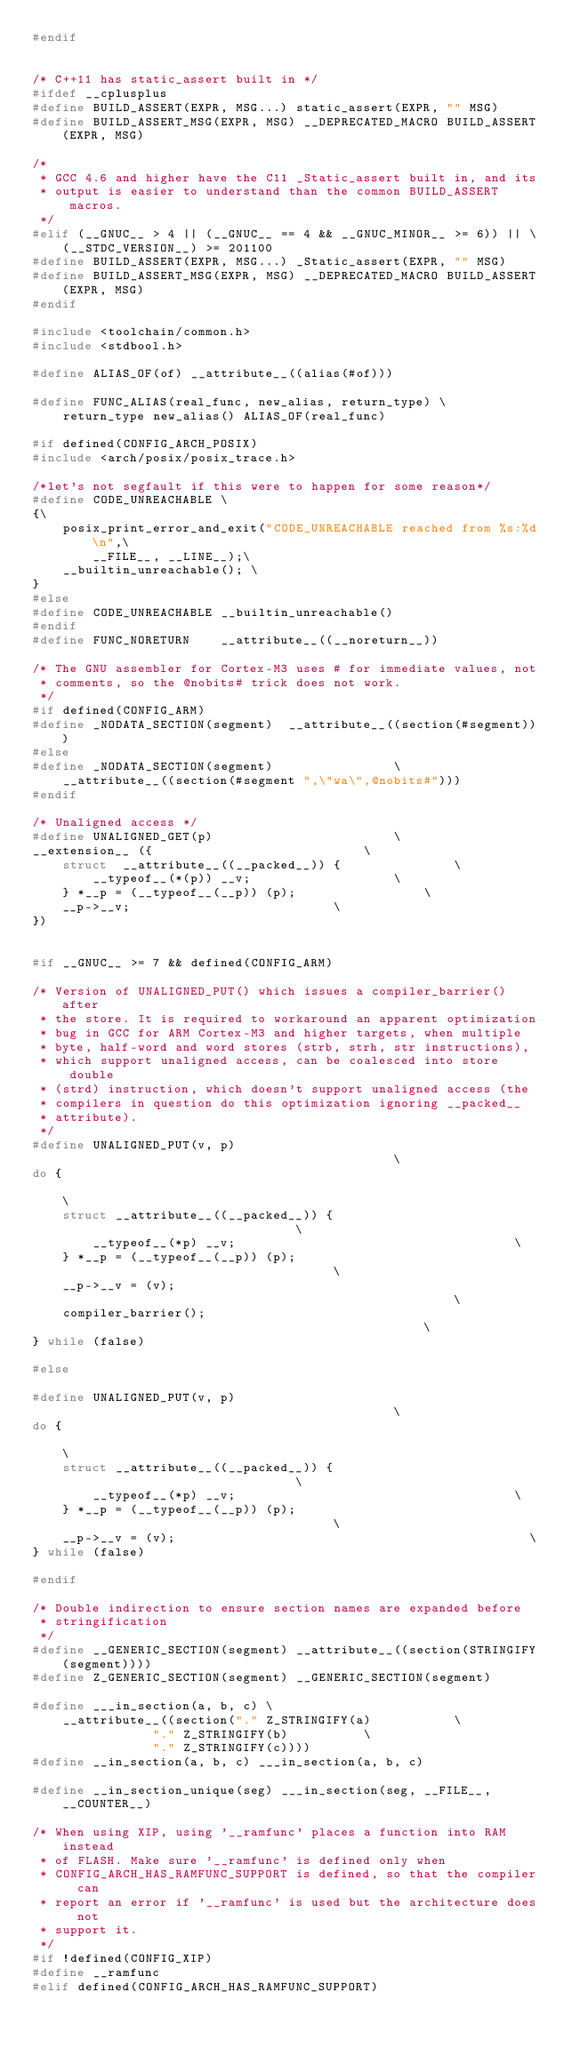<code> <loc_0><loc_0><loc_500><loc_500><_C_>#endif


/* C++11 has static_assert built in */
#ifdef __cplusplus
#define BUILD_ASSERT(EXPR, MSG...) static_assert(EXPR, "" MSG)
#define BUILD_ASSERT_MSG(EXPR, MSG) __DEPRECATED_MACRO BUILD_ASSERT(EXPR, MSG)

/*
 * GCC 4.6 and higher have the C11 _Static_assert built in, and its
 * output is easier to understand than the common BUILD_ASSERT macros.
 */
#elif (__GNUC__ > 4 || (__GNUC__ == 4 && __GNUC_MINOR__ >= 6)) || \
	(__STDC_VERSION__) >= 201100
#define BUILD_ASSERT(EXPR, MSG...) _Static_assert(EXPR, "" MSG)
#define BUILD_ASSERT_MSG(EXPR, MSG) __DEPRECATED_MACRO BUILD_ASSERT(EXPR, MSG)
#endif

#include <toolchain/common.h>
#include <stdbool.h>

#define ALIAS_OF(of) __attribute__((alias(#of)))

#define FUNC_ALIAS(real_func, new_alias, return_type) \
	return_type new_alias() ALIAS_OF(real_func)

#if defined(CONFIG_ARCH_POSIX)
#include <arch/posix/posix_trace.h>

/*let's not segfault if this were to happen for some reason*/
#define CODE_UNREACHABLE \
{\
	posix_print_error_and_exit("CODE_UNREACHABLE reached from %s:%d\n",\
		__FILE__, __LINE__);\
	__builtin_unreachable(); \
}
#else
#define CODE_UNREACHABLE __builtin_unreachable()
#endif
#define FUNC_NORETURN    __attribute__((__noreturn__))

/* The GNU assembler for Cortex-M3 uses # for immediate values, not
 * comments, so the @nobits# trick does not work.
 */
#if defined(CONFIG_ARM)
#define _NODATA_SECTION(segment)  __attribute__((section(#segment)))
#else
#define _NODATA_SECTION(segment)				\
	__attribute__((section(#segment ",\"wa\",@nobits#")))
#endif

/* Unaligned access */
#define UNALIGNED_GET(p)						\
__extension__ ({							\
	struct  __attribute__((__packed__)) {				\
		__typeof__(*(p)) __v;					\
	} *__p = (__typeof__(__p)) (p);					\
	__p->__v;							\
})


#if __GNUC__ >= 7 && defined(CONFIG_ARM)

/* Version of UNALIGNED_PUT() which issues a compiler_barrier() after
 * the store. It is required to workaround an apparent optimization
 * bug in GCC for ARM Cortex-M3 and higher targets, when multiple
 * byte, half-word and word stores (strb, strh, str instructions),
 * which support unaligned access, can be coalesced into store double
 * (strd) instruction, which doesn't support unaligned access (the
 * compilers in question do this optimization ignoring __packed__
 * attribute).
 */
#define UNALIGNED_PUT(v, p)                                             \
do {                                                                    \
	struct __attribute__((__packed__)) {                            \
		__typeof__(*p) __v;                                     \
	} *__p = (__typeof__(__p)) (p);                                 \
	__p->__v = (v);                                                 \
	compiler_barrier();                                             \
} while (false)

#else

#define UNALIGNED_PUT(v, p)                                             \
do {                                                                    \
	struct __attribute__((__packed__)) {                            \
		__typeof__(*p) __v;                                     \
	} *__p = (__typeof__(__p)) (p);                                 \
	__p->__v = (v);                                               \
} while (false)

#endif

/* Double indirection to ensure section names are expanded before
 * stringification
 */
#define __GENERIC_SECTION(segment) __attribute__((section(STRINGIFY(segment))))
#define Z_GENERIC_SECTION(segment) __GENERIC_SECTION(segment)

#define ___in_section(a, b, c) \
	__attribute__((section("." Z_STRINGIFY(a)			\
				"." Z_STRINGIFY(b)			\
				"." Z_STRINGIFY(c))))
#define __in_section(a, b, c) ___in_section(a, b, c)

#define __in_section_unique(seg) ___in_section(seg, __FILE__, __COUNTER__)

/* When using XIP, using '__ramfunc' places a function into RAM instead
 * of FLASH. Make sure '__ramfunc' is defined only when
 * CONFIG_ARCH_HAS_RAMFUNC_SUPPORT is defined, so that the compiler can
 * report an error if '__ramfunc' is used but the architecture does not
 * support it.
 */
#if !defined(CONFIG_XIP)
#define __ramfunc
#elif defined(CONFIG_ARCH_HAS_RAMFUNC_SUPPORT)</code> 